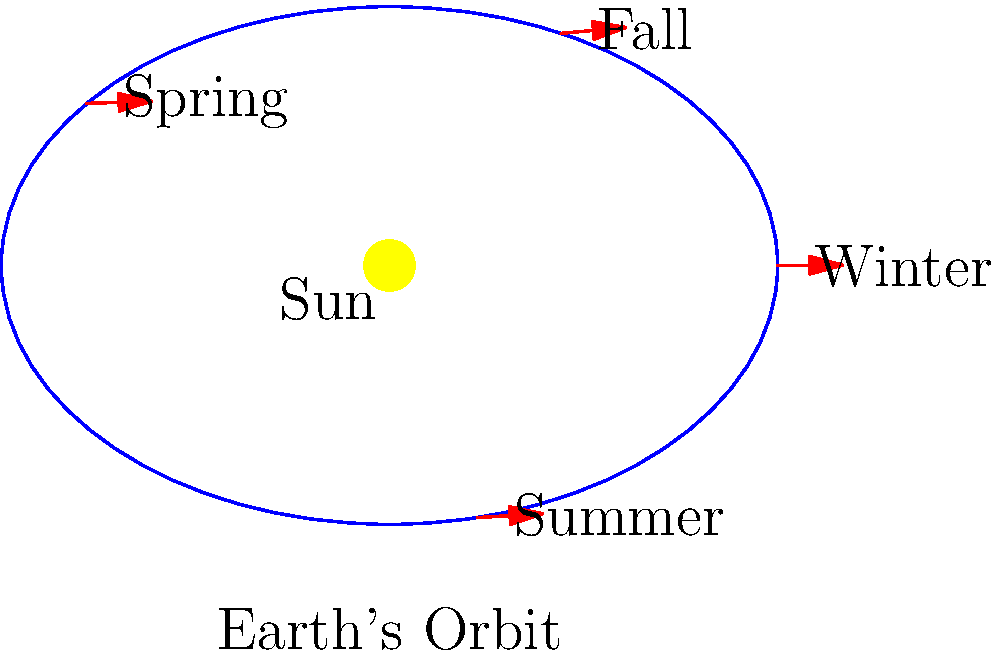As a dental hygiene corporation executive looking to expand your market reach globally, understanding seasonal variations is crucial. How does Earth's elliptical orbit and axial tilt contribute to the occurrence of seasons, and what implications might this have for your product development and marketing strategies in different hemispheres? 1. Earth's orbit:
   - Earth orbits the Sun in an elliptical path, not a perfect circle.
   - The average distance from Earth to the Sun is about 149.6 million km.

2. Axial tilt:
   - Earth's axis is tilted at an angle of approximately 23.5° relative to its orbital plane.
   - This tilt remains constant throughout the orbit.

3. Seasonal changes:
   - The axial tilt causes different parts of Earth to receive varying amounts of sunlight throughout the year.
   - When the Northern Hemisphere is tilted towards the Sun, it experiences summer, while the Southern Hemisphere experiences winter, and vice versa.

4. Elliptical orbit effects:
   - The elliptical orbit causes a slight variation in Earth's distance from the Sun.
   - Earth is closest to the Sun (perihelion) in early January and farthest (aphelion) in early July.
   - However, this distance variation has a minimal effect on seasons compared to the axial tilt.

5. Implications for dental hygiene products:
   - Different seasons may affect oral health habits and product usage.
   - In colder seasons, people might consume more hot beverages, potentially increasing teeth sensitivity or staining.
   - In warmer seasons, increased outdoor activities might lead to higher demand for on-the-go oral care products.

6. Marketing strategies:
   - Develop seasonally-targeted marketing campaigns for each hemisphere.
   - Adjust product formulations or packaging to address seasonal oral health concerns.
   - Time product launches to coincide with seasonal changes in different global markets.

7. Product development:
   - Create season-specific products (e.g., sensitivity relief for winter, breath fresheners for summer).
   - Develop travel-sized products for summer vacation seasons.
   - Consider UV protection in packaging for products used outdoors during summer months.
Answer: Earth's axial tilt primarily causes seasons, while its elliptical orbit has minimal effect. This knowledge can inform season-specific product development and marketing strategies for dental hygiene products in different hemispheres. 